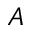<formula> <loc_0><loc_0><loc_500><loc_500>A</formula> 